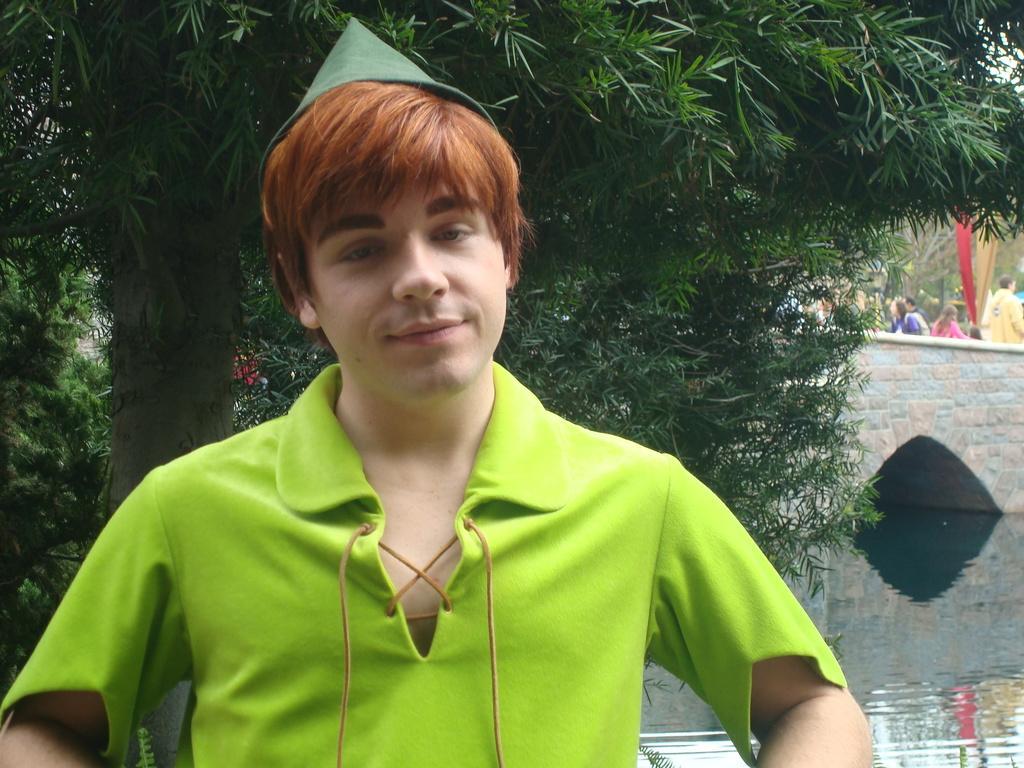Please provide a concise description of this image. In this picture I can see a man in front and I see that he is wearing green color t-shirt and wearing a hat. In the middle of this picture, I can see the water, few plants and in the background I can see the bridge, on which there are few people. 